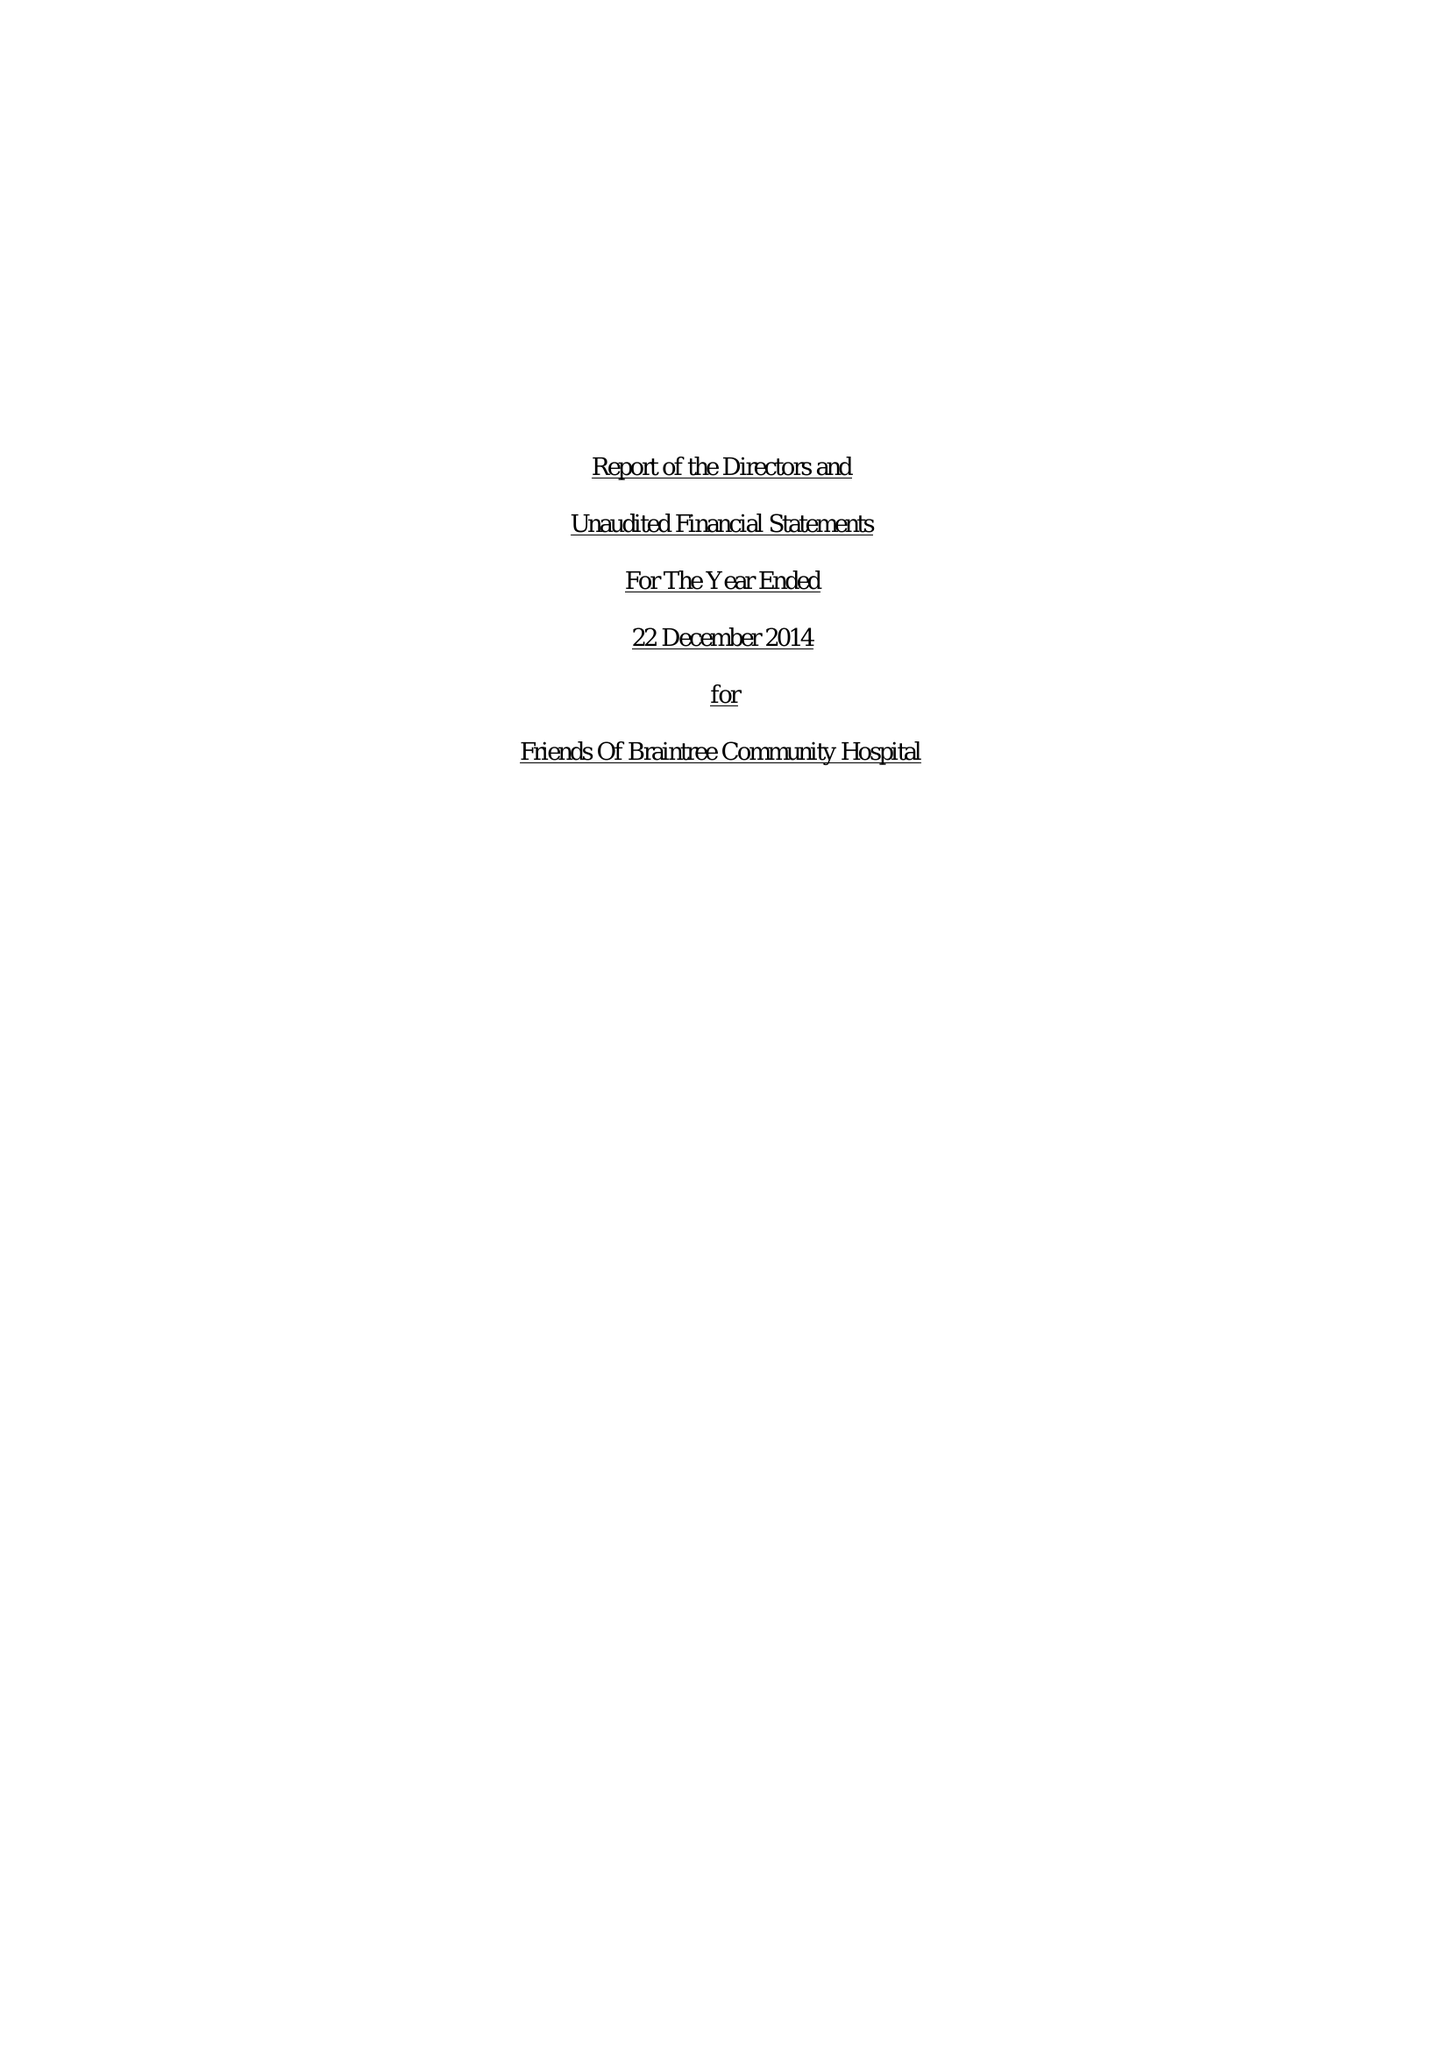What is the value for the charity_number?
Answer the question using a single word or phrase. 1144843 